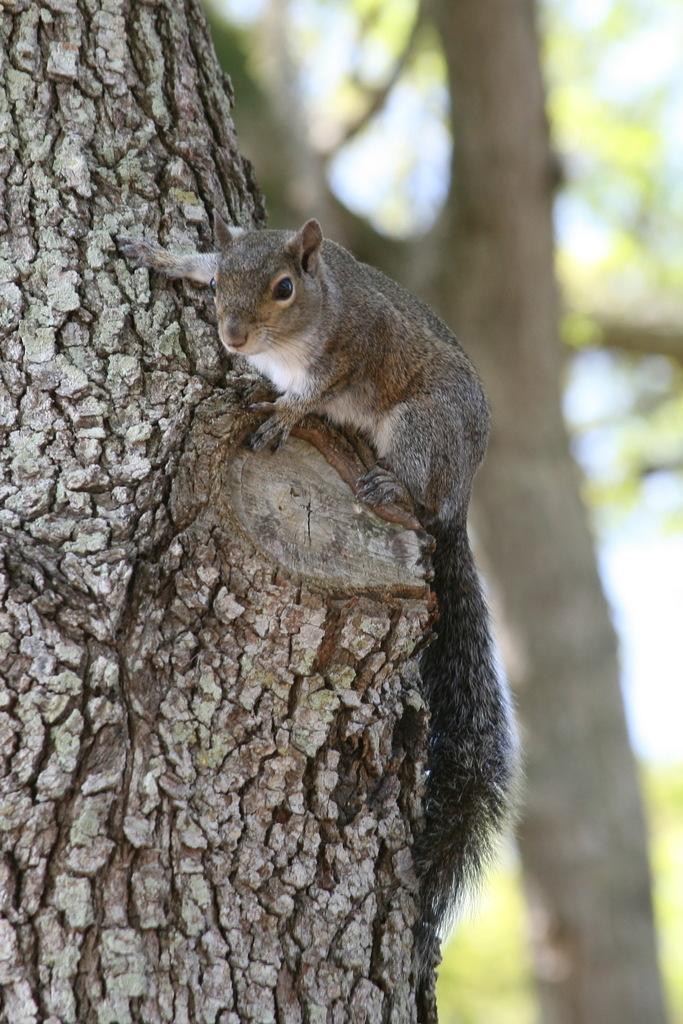Describe this image in one or two sentences. Background portion of the picture is blurry and we can see a tree trunk. In this picture we can see a squirrel on a branch. 